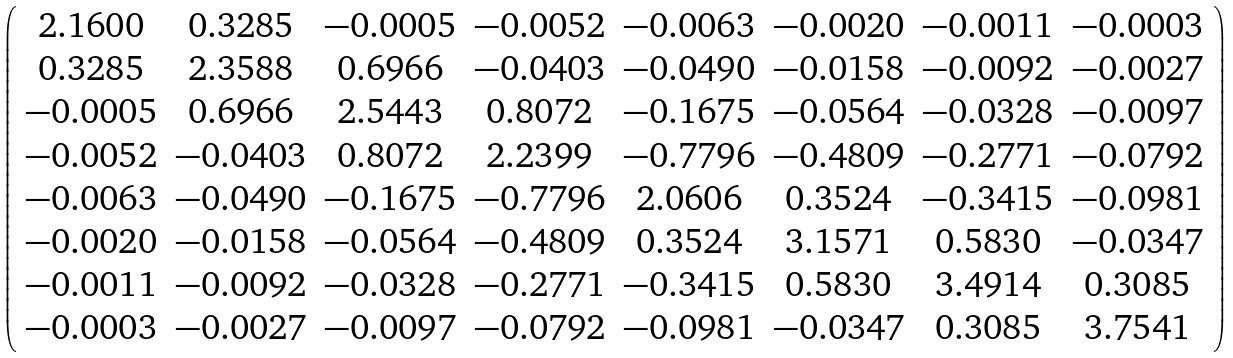Convert formula to latex. <formula><loc_0><loc_0><loc_500><loc_500>\left ( \begin{array} { c c c c c c c c } { 2 . 1 6 0 0 } & { 0 . 3 2 8 5 } & - 0 . 0 0 0 5 & - 0 . 0 0 5 2 & - 0 . 0 0 6 3 & - 0 . 0 0 2 0 & - 0 . 0 0 1 1 & - 0 . 0 0 0 3 \\ { 0 . 3 2 8 5 } & { 2 . 3 5 8 8 } & { 0 . 6 9 6 6 } & - 0 . 0 4 0 3 & - 0 . 0 4 9 0 & - 0 . 0 1 5 8 & - 0 . 0 0 9 2 & - 0 . 0 0 2 7 \\ - 0 . 0 0 0 5 & { 0 . 6 9 6 6 } & { 2 . 5 4 4 3 } & { 0 . 8 0 7 2 } & - 0 . 1 6 7 5 & - 0 . 0 5 6 4 & - 0 . 0 3 2 8 & - 0 . 0 0 9 7 \\ - 0 . 0 0 5 2 & - 0 . 0 4 0 3 & { 0 . 8 0 7 2 } & { 2 . 2 3 9 9 } & - 0 . 7 7 9 6 & - 0 . 4 8 0 9 & - 0 . 2 7 7 1 & - 0 . 0 7 9 2 \\ - 0 . 0 0 6 3 & - 0 . 0 4 9 0 & - 0 . 1 6 7 5 & - 0 . 7 7 9 6 & { 2 . 0 6 0 6 } & { 0 . 3 5 2 4 } & - 0 . 3 4 1 5 & - 0 . 0 9 8 1 \\ - 0 . 0 0 2 0 & - 0 . 0 1 5 8 & - 0 . 0 5 6 4 & - 0 . 4 8 0 9 & { 0 . 3 5 2 4 } & { 3 . 1 5 7 1 } & { 0 . 5 8 3 0 } & - 0 . 0 3 4 7 \\ - 0 . 0 0 1 1 & - 0 . 0 0 9 2 & - 0 . 0 3 2 8 & - 0 . 2 7 7 1 & - 0 . 3 4 1 5 & { 0 . 5 8 3 0 } & { 3 . 4 9 1 4 } & { 0 . 3 0 8 5 } \\ - 0 . 0 0 0 3 & - 0 . 0 0 2 7 & - 0 . 0 0 9 7 & - 0 . 0 7 9 2 & - 0 . 0 9 8 1 & - 0 . 0 3 4 7 & { 0 . 3 0 8 5 } & { 3 . 7 5 4 1 } \\ \end{array} \right )</formula> 